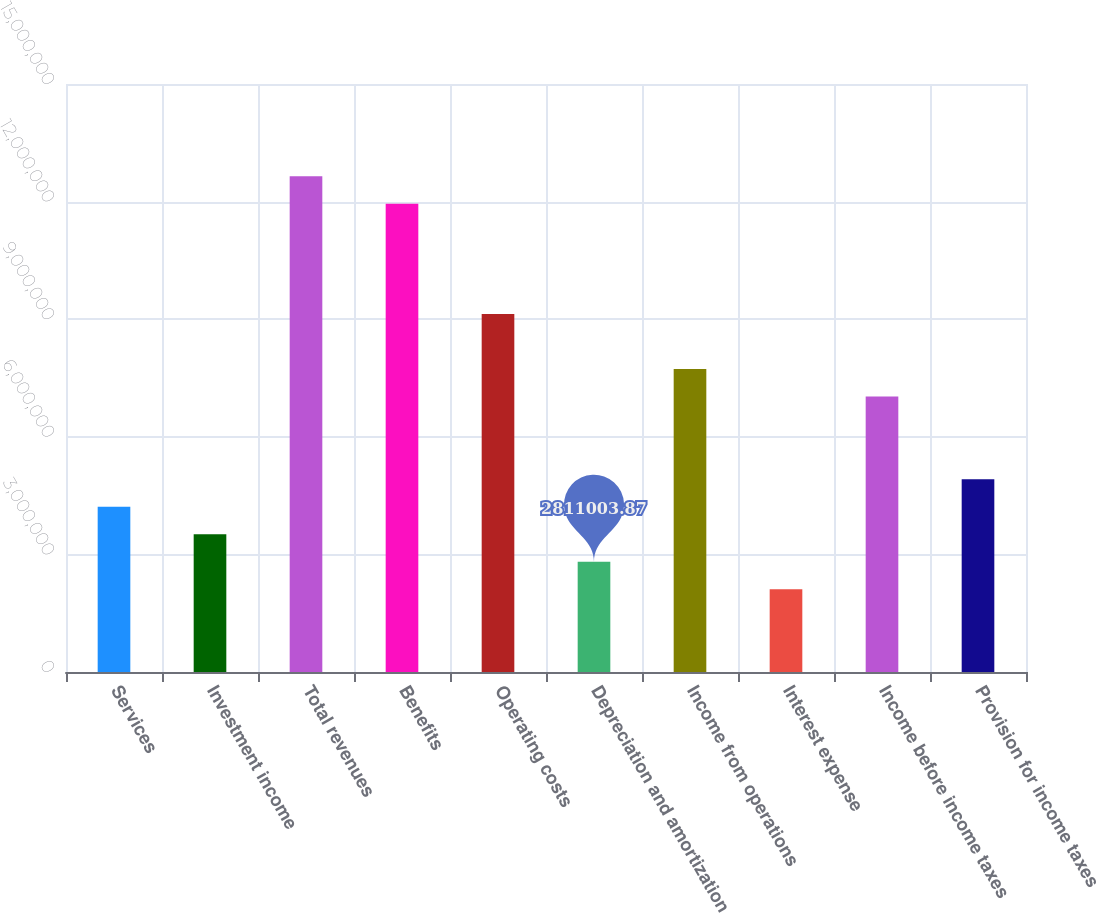Convert chart. <chart><loc_0><loc_0><loc_500><loc_500><bar_chart><fcel>Services<fcel>Investment income<fcel>Total revenues<fcel>Benefits<fcel>Operating costs<fcel>Depreciation and amortization<fcel>Income from operations<fcel>Interest expense<fcel>Income before income taxes<fcel>Provision for income taxes<nl><fcel>4.2165e+06<fcel>3.51375e+06<fcel>1.26495e+07<fcel>1.19467e+07<fcel>9.13575e+06<fcel>2.811e+06<fcel>7.73025e+06<fcel>2.10825e+06<fcel>7.0275e+06<fcel>4.91925e+06<nl></chart> 